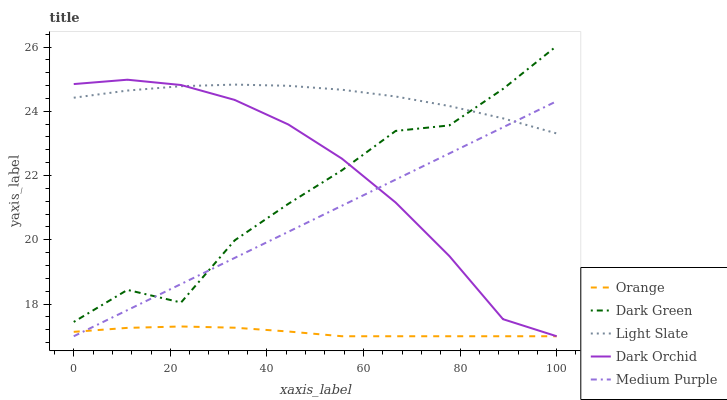Does Medium Purple have the minimum area under the curve?
Answer yes or no. No. Does Medium Purple have the maximum area under the curve?
Answer yes or no. No. Is Light Slate the smoothest?
Answer yes or no. No. Is Light Slate the roughest?
Answer yes or no. No. Does Light Slate have the lowest value?
Answer yes or no. No. Does Light Slate have the highest value?
Answer yes or no. No. Is Orange less than Light Slate?
Answer yes or no. Yes. Is Dark Green greater than Orange?
Answer yes or no. Yes. Does Orange intersect Light Slate?
Answer yes or no. No. 